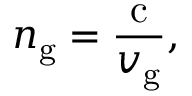Convert formula to latex. <formula><loc_0><loc_0><loc_500><loc_500>n _ { g } = { \frac { c } { v _ { g } } } ,</formula> 